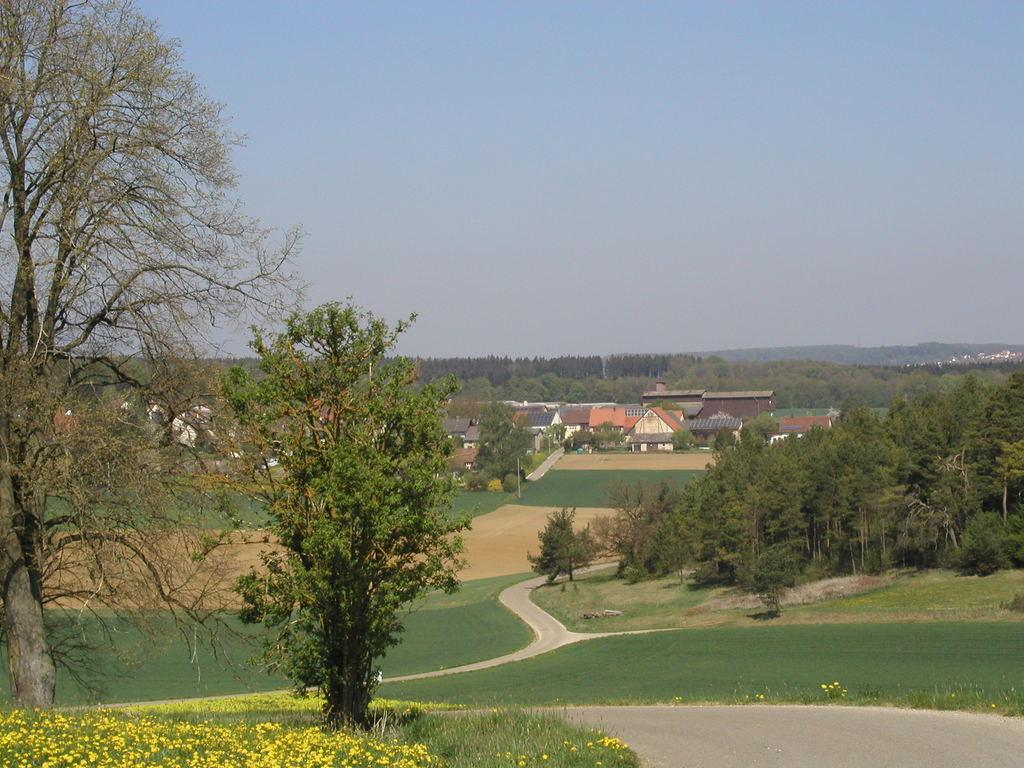What type of vegetation can be seen in the image? There are trees, flowers, and grass in the image. What structures are visible in the background of the image? There are houses and trees in the background of the image. What part of the natural environment is visible in the image? The sky is visible in the background of the image. What type of drug can be seen in the image? There is no drug present in the image. 